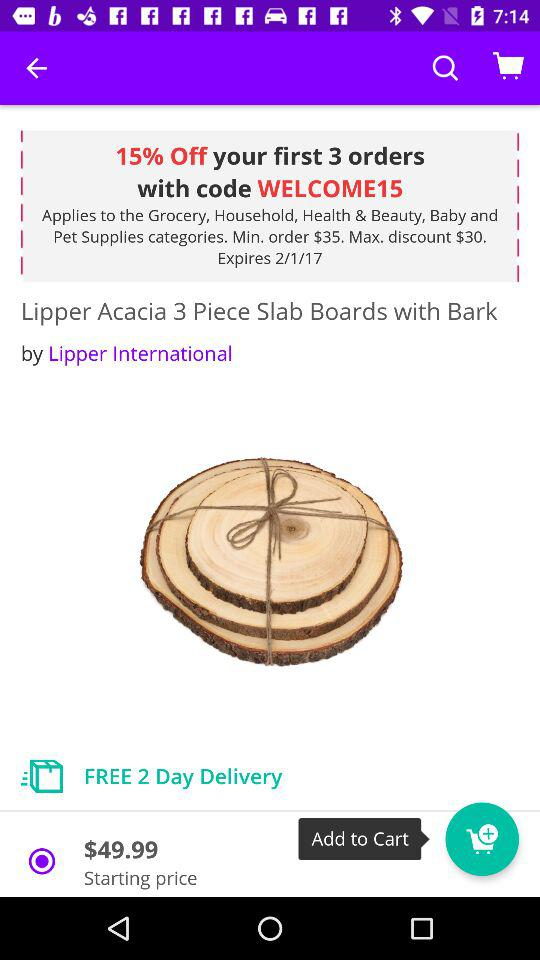What is the discount code? The discount code is "WELCOME15". 